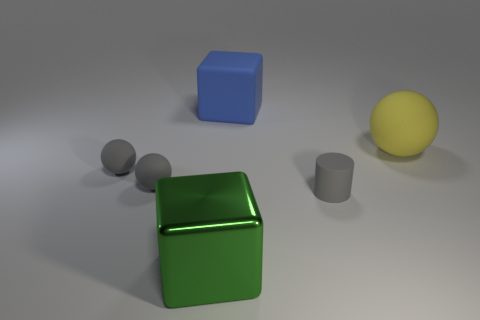Add 1 big green metal things. How many objects exist? 7 Subtract all cylinders. How many objects are left? 5 Subtract all large cubes. Subtract all large purple cylinders. How many objects are left? 4 Add 5 blue things. How many blue things are left? 6 Add 5 blue rubber things. How many blue rubber things exist? 6 Subtract 0 brown cylinders. How many objects are left? 6 